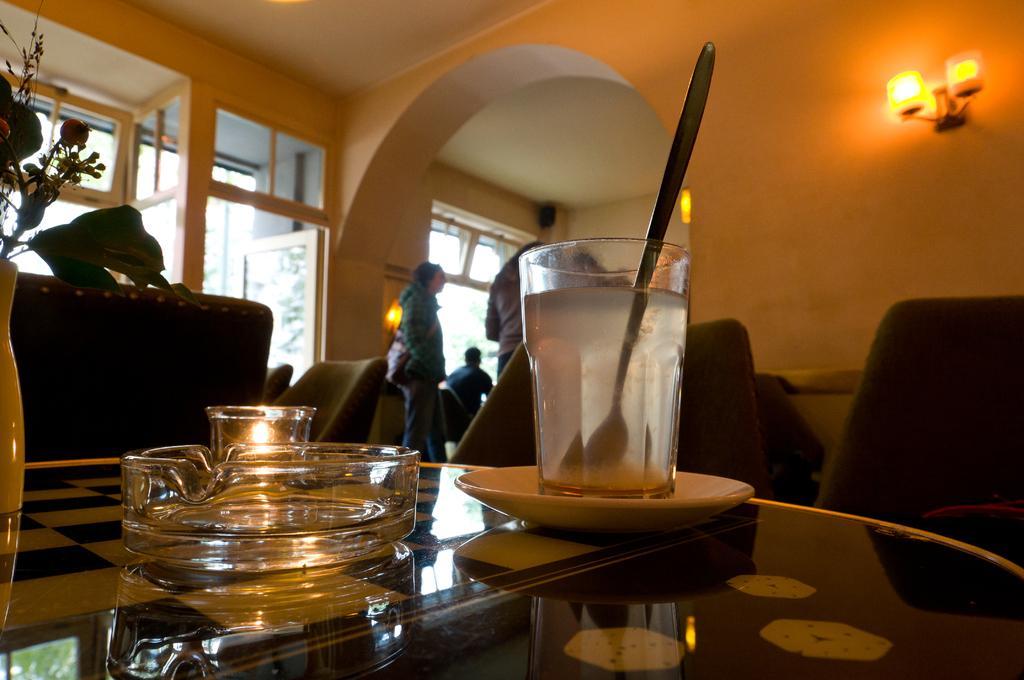Could you give a brief overview of what you see in this image? There is a saucer, glass, inside the glass spoon and water, tray, vase with flowers are kept on a table. There are chairs in this room. In the background there are person's, wall, on the wall there is a light, windows, door is in the background. 